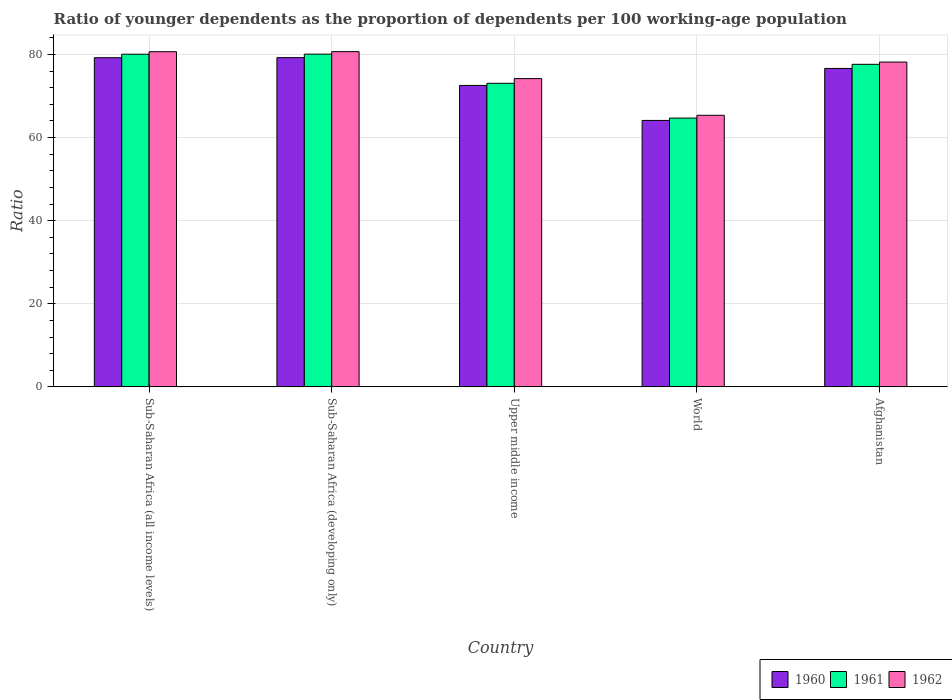How many different coloured bars are there?
Provide a succinct answer. 3. How many groups of bars are there?
Keep it short and to the point. 5. Are the number of bars on each tick of the X-axis equal?
Keep it short and to the point. Yes. How many bars are there on the 1st tick from the left?
Your answer should be compact. 3. What is the label of the 1st group of bars from the left?
Keep it short and to the point. Sub-Saharan Africa (all income levels). In how many cases, is the number of bars for a given country not equal to the number of legend labels?
Your response must be concise. 0. What is the age dependency ratio(young) in 1961 in World?
Give a very brief answer. 64.68. Across all countries, what is the maximum age dependency ratio(young) in 1962?
Ensure brevity in your answer.  80.68. Across all countries, what is the minimum age dependency ratio(young) in 1960?
Offer a very short reply. 64.12. In which country was the age dependency ratio(young) in 1960 maximum?
Your answer should be very brief. Sub-Saharan Africa (developing only). What is the total age dependency ratio(young) in 1960 in the graph?
Ensure brevity in your answer.  371.74. What is the difference between the age dependency ratio(young) in 1961 in Upper middle income and that in World?
Ensure brevity in your answer.  8.37. What is the difference between the age dependency ratio(young) in 1960 in Sub-Saharan Africa (all income levels) and the age dependency ratio(young) in 1962 in Sub-Saharan Africa (developing only)?
Ensure brevity in your answer.  -1.46. What is the average age dependency ratio(young) in 1962 per country?
Offer a very short reply. 75.81. What is the difference between the age dependency ratio(young) of/in 1961 and age dependency ratio(young) of/in 1962 in Sub-Saharan Africa (all income levels)?
Your response must be concise. -0.6. What is the ratio of the age dependency ratio(young) in 1961 in Afghanistan to that in World?
Ensure brevity in your answer.  1.2. Is the age dependency ratio(young) in 1962 in Sub-Saharan Africa (all income levels) less than that in World?
Offer a terse response. No. What is the difference between the highest and the second highest age dependency ratio(young) in 1961?
Your answer should be very brief. 0.02. What is the difference between the highest and the lowest age dependency ratio(young) in 1961?
Offer a terse response. 15.39. Is it the case that in every country, the sum of the age dependency ratio(young) in 1960 and age dependency ratio(young) in 1962 is greater than the age dependency ratio(young) in 1961?
Give a very brief answer. Yes. How many bars are there?
Provide a short and direct response. 15. How many countries are there in the graph?
Offer a terse response. 5. What is the difference between two consecutive major ticks on the Y-axis?
Provide a succinct answer. 20. Are the values on the major ticks of Y-axis written in scientific E-notation?
Make the answer very short. No. Does the graph contain any zero values?
Your answer should be compact. No. Where does the legend appear in the graph?
Ensure brevity in your answer.  Bottom right. How many legend labels are there?
Ensure brevity in your answer.  3. How are the legend labels stacked?
Offer a very short reply. Horizontal. What is the title of the graph?
Your response must be concise. Ratio of younger dependents as the proportion of dependents per 100 working-age population. Does "1992" appear as one of the legend labels in the graph?
Keep it short and to the point. No. What is the label or title of the Y-axis?
Give a very brief answer. Ratio. What is the Ratio of 1960 in Sub-Saharan Africa (all income levels)?
Your answer should be very brief. 79.21. What is the Ratio in 1961 in Sub-Saharan Africa (all income levels)?
Offer a very short reply. 80.06. What is the Ratio of 1962 in Sub-Saharan Africa (all income levels)?
Offer a terse response. 80.66. What is the Ratio of 1960 in Sub-Saharan Africa (developing only)?
Make the answer very short. 79.23. What is the Ratio of 1961 in Sub-Saharan Africa (developing only)?
Provide a succinct answer. 80.07. What is the Ratio in 1962 in Sub-Saharan Africa (developing only)?
Give a very brief answer. 80.68. What is the Ratio of 1960 in Upper middle income?
Offer a terse response. 72.54. What is the Ratio of 1961 in Upper middle income?
Your answer should be very brief. 73.05. What is the Ratio in 1962 in Upper middle income?
Keep it short and to the point. 74.18. What is the Ratio of 1960 in World?
Provide a short and direct response. 64.12. What is the Ratio of 1961 in World?
Keep it short and to the point. 64.68. What is the Ratio of 1962 in World?
Keep it short and to the point. 65.36. What is the Ratio in 1960 in Afghanistan?
Offer a terse response. 76.63. What is the Ratio in 1961 in Afghanistan?
Provide a succinct answer. 77.62. What is the Ratio in 1962 in Afghanistan?
Provide a succinct answer. 78.17. Across all countries, what is the maximum Ratio of 1960?
Provide a succinct answer. 79.23. Across all countries, what is the maximum Ratio of 1961?
Offer a very short reply. 80.07. Across all countries, what is the maximum Ratio in 1962?
Ensure brevity in your answer.  80.68. Across all countries, what is the minimum Ratio of 1960?
Ensure brevity in your answer.  64.12. Across all countries, what is the minimum Ratio in 1961?
Your answer should be compact. 64.68. Across all countries, what is the minimum Ratio of 1962?
Offer a very short reply. 65.36. What is the total Ratio in 1960 in the graph?
Give a very brief answer. 371.74. What is the total Ratio of 1961 in the graph?
Give a very brief answer. 375.49. What is the total Ratio of 1962 in the graph?
Keep it short and to the point. 379.04. What is the difference between the Ratio of 1960 in Sub-Saharan Africa (all income levels) and that in Sub-Saharan Africa (developing only)?
Give a very brief answer. -0.02. What is the difference between the Ratio in 1961 in Sub-Saharan Africa (all income levels) and that in Sub-Saharan Africa (developing only)?
Make the answer very short. -0.02. What is the difference between the Ratio in 1962 in Sub-Saharan Africa (all income levels) and that in Sub-Saharan Africa (developing only)?
Offer a terse response. -0.02. What is the difference between the Ratio of 1960 in Sub-Saharan Africa (all income levels) and that in Upper middle income?
Offer a very short reply. 6.67. What is the difference between the Ratio of 1961 in Sub-Saharan Africa (all income levels) and that in Upper middle income?
Offer a very short reply. 7. What is the difference between the Ratio in 1962 in Sub-Saharan Africa (all income levels) and that in Upper middle income?
Your answer should be compact. 6.48. What is the difference between the Ratio in 1960 in Sub-Saharan Africa (all income levels) and that in World?
Offer a very short reply. 15.09. What is the difference between the Ratio of 1961 in Sub-Saharan Africa (all income levels) and that in World?
Provide a succinct answer. 15.37. What is the difference between the Ratio of 1962 in Sub-Saharan Africa (all income levels) and that in World?
Offer a very short reply. 15.3. What is the difference between the Ratio of 1960 in Sub-Saharan Africa (all income levels) and that in Afghanistan?
Your answer should be compact. 2.58. What is the difference between the Ratio in 1961 in Sub-Saharan Africa (all income levels) and that in Afghanistan?
Provide a succinct answer. 2.43. What is the difference between the Ratio in 1962 in Sub-Saharan Africa (all income levels) and that in Afghanistan?
Provide a short and direct response. 2.49. What is the difference between the Ratio in 1960 in Sub-Saharan Africa (developing only) and that in Upper middle income?
Keep it short and to the point. 6.69. What is the difference between the Ratio of 1961 in Sub-Saharan Africa (developing only) and that in Upper middle income?
Your response must be concise. 7.02. What is the difference between the Ratio of 1962 in Sub-Saharan Africa (developing only) and that in Upper middle income?
Your answer should be very brief. 6.49. What is the difference between the Ratio of 1960 in Sub-Saharan Africa (developing only) and that in World?
Your answer should be very brief. 15.11. What is the difference between the Ratio of 1961 in Sub-Saharan Africa (developing only) and that in World?
Provide a succinct answer. 15.39. What is the difference between the Ratio in 1962 in Sub-Saharan Africa (developing only) and that in World?
Provide a short and direct response. 15.32. What is the difference between the Ratio in 1960 in Sub-Saharan Africa (developing only) and that in Afghanistan?
Your response must be concise. 2.6. What is the difference between the Ratio in 1961 in Sub-Saharan Africa (developing only) and that in Afghanistan?
Ensure brevity in your answer.  2.45. What is the difference between the Ratio of 1962 in Sub-Saharan Africa (developing only) and that in Afghanistan?
Your answer should be compact. 2.51. What is the difference between the Ratio of 1960 in Upper middle income and that in World?
Offer a very short reply. 8.42. What is the difference between the Ratio of 1961 in Upper middle income and that in World?
Provide a short and direct response. 8.37. What is the difference between the Ratio of 1962 in Upper middle income and that in World?
Your answer should be very brief. 8.82. What is the difference between the Ratio in 1960 in Upper middle income and that in Afghanistan?
Keep it short and to the point. -4.09. What is the difference between the Ratio of 1961 in Upper middle income and that in Afghanistan?
Your answer should be compact. -4.57. What is the difference between the Ratio in 1962 in Upper middle income and that in Afghanistan?
Offer a terse response. -3.98. What is the difference between the Ratio in 1960 in World and that in Afghanistan?
Your answer should be compact. -12.51. What is the difference between the Ratio in 1961 in World and that in Afghanistan?
Make the answer very short. -12.94. What is the difference between the Ratio of 1962 in World and that in Afghanistan?
Offer a terse response. -12.81. What is the difference between the Ratio in 1960 in Sub-Saharan Africa (all income levels) and the Ratio in 1961 in Sub-Saharan Africa (developing only)?
Your answer should be compact. -0.86. What is the difference between the Ratio of 1960 in Sub-Saharan Africa (all income levels) and the Ratio of 1962 in Sub-Saharan Africa (developing only)?
Provide a succinct answer. -1.46. What is the difference between the Ratio of 1961 in Sub-Saharan Africa (all income levels) and the Ratio of 1962 in Sub-Saharan Africa (developing only)?
Ensure brevity in your answer.  -0.62. What is the difference between the Ratio of 1960 in Sub-Saharan Africa (all income levels) and the Ratio of 1961 in Upper middle income?
Offer a very short reply. 6.16. What is the difference between the Ratio in 1960 in Sub-Saharan Africa (all income levels) and the Ratio in 1962 in Upper middle income?
Ensure brevity in your answer.  5.03. What is the difference between the Ratio of 1961 in Sub-Saharan Africa (all income levels) and the Ratio of 1962 in Upper middle income?
Offer a terse response. 5.87. What is the difference between the Ratio in 1960 in Sub-Saharan Africa (all income levels) and the Ratio in 1961 in World?
Your response must be concise. 14.53. What is the difference between the Ratio of 1960 in Sub-Saharan Africa (all income levels) and the Ratio of 1962 in World?
Your response must be concise. 13.86. What is the difference between the Ratio of 1961 in Sub-Saharan Africa (all income levels) and the Ratio of 1962 in World?
Provide a succinct answer. 14.7. What is the difference between the Ratio of 1960 in Sub-Saharan Africa (all income levels) and the Ratio of 1961 in Afghanistan?
Give a very brief answer. 1.59. What is the difference between the Ratio of 1960 in Sub-Saharan Africa (all income levels) and the Ratio of 1962 in Afghanistan?
Make the answer very short. 1.05. What is the difference between the Ratio of 1961 in Sub-Saharan Africa (all income levels) and the Ratio of 1962 in Afghanistan?
Give a very brief answer. 1.89. What is the difference between the Ratio of 1960 in Sub-Saharan Africa (developing only) and the Ratio of 1961 in Upper middle income?
Give a very brief answer. 6.18. What is the difference between the Ratio in 1960 in Sub-Saharan Africa (developing only) and the Ratio in 1962 in Upper middle income?
Your answer should be compact. 5.05. What is the difference between the Ratio of 1961 in Sub-Saharan Africa (developing only) and the Ratio of 1962 in Upper middle income?
Make the answer very short. 5.89. What is the difference between the Ratio of 1960 in Sub-Saharan Africa (developing only) and the Ratio of 1961 in World?
Your response must be concise. 14.55. What is the difference between the Ratio in 1960 in Sub-Saharan Africa (developing only) and the Ratio in 1962 in World?
Provide a succinct answer. 13.88. What is the difference between the Ratio in 1961 in Sub-Saharan Africa (developing only) and the Ratio in 1962 in World?
Offer a terse response. 14.72. What is the difference between the Ratio of 1960 in Sub-Saharan Africa (developing only) and the Ratio of 1961 in Afghanistan?
Your answer should be compact. 1.61. What is the difference between the Ratio in 1960 in Sub-Saharan Africa (developing only) and the Ratio in 1962 in Afghanistan?
Offer a terse response. 1.07. What is the difference between the Ratio of 1961 in Sub-Saharan Africa (developing only) and the Ratio of 1962 in Afghanistan?
Offer a terse response. 1.91. What is the difference between the Ratio of 1960 in Upper middle income and the Ratio of 1961 in World?
Offer a terse response. 7.86. What is the difference between the Ratio of 1960 in Upper middle income and the Ratio of 1962 in World?
Your answer should be very brief. 7.19. What is the difference between the Ratio of 1961 in Upper middle income and the Ratio of 1962 in World?
Give a very brief answer. 7.7. What is the difference between the Ratio in 1960 in Upper middle income and the Ratio in 1961 in Afghanistan?
Provide a succinct answer. -5.08. What is the difference between the Ratio of 1960 in Upper middle income and the Ratio of 1962 in Afghanistan?
Ensure brevity in your answer.  -5.62. What is the difference between the Ratio of 1961 in Upper middle income and the Ratio of 1962 in Afghanistan?
Ensure brevity in your answer.  -5.11. What is the difference between the Ratio of 1960 in World and the Ratio of 1961 in Afghanistan?
Your answer should be very brief. -13.5. What is the difference between the Ratio of 1960 in World and the Ratio of 1962 in Afghanistan?
Your answer should be compact. -14.04. What is the difference between the Ratio of 1961 in World and the Ratio of 1962 in Afghanistan?
Give a very brief answer. -13.48. What is the average Ratio in 1960 per country?
Provide a short and direct response. 74.35. What is the average Ratio in 1961 per country?
Make the answer very short. 75.1. What is the average Ratio of 1962 per country?
Your response must be concise. 75.81. What is the difference between the Ratio of 1960 and Ratio of 1961 in Sub-Saharan Africa (all income levels)?
Your response must be concise. -0.84. What is the difference between the Ratio of 1960 and Ratio of 1962 in Sub-Saharan Africa (all income levels)?
Provide a short and direct response. -1.44. What is the difference between the Ratio of 1961 and Ratio of 1962 in Sub-Saharan Africa (all income levels)?
Your response must be concise. -0.6. What is the difference between the Ratio in 1960 and Ratio in 1961 in Sub-Saharan Africa (developing only)?
Offer a terse response. -0.84. What is the difference between the Ratio of 1960 and Ratio of 1962 in Sub-Saharan Africa (developing only)?
Make the answer very short. -1.44. What is the difference between the Ratio of 1961 and Ratio of 1962 in Sub-Saharan Africa (developing only)?
Your response must be concise. -0.6. What is the difference between the Ratio of 1960 and Ratio of 1961 in Upper middle income?
Offer a very short reply. -0.51. What is the difference between the Ratio in 1960 and Ratio in 1962 in Upper middle income?
Provide a short and direct response. -1.64. What is the difference between the Ratio of 1961 and Ratio of 1962 in Upper middle income?
Ensure brevity in your answer.  -1.13. What is the difference between the Ratio of 1960 and Ratio of 1961 in World?
Provide a short and direct response. -0.56. What is the difference between the Ratio of 1960 and Ratio of 1962 in World?
Offer a very short reply. -1.24. What is the difference between the Ratio of 1961 and Ratio of 1962 in World?
Give a very brief answer. -0.67. What is the difference between the Ratio in 1960 and Ratio in 1961 in Afghanistan?
Ensure brevity in your answer.  -0.99. What is the difference between the Ratio in 1960 and Ratio in 1962 in Afghanistan?
Make the answer very short. -1.53. What is the difference between the Ratio of 1961 and Ratio of 1962 in Afghanistan?
Provide a short and direct response. -0.54. What is the ratio of the Ratio in 1962 in Sub-Saharan Africa (all income levels) to that in Sub-Saharan Africa (developing only)?
Keep it short and to the point. 1. What is the ratio of the Ratio of 1960 in Sub-Saharan Africa (all income levels) to that in Upper middle income?
Provide a short and direct response. 1.09. What is the ratio of the Ratio in 1961 in Sub-Saharan Africa (all income levels) to that in Upper middle income?
Ensure brevity in your answer.  1.1. What is the ratio of the Ratio of 1962 in Sub-Saharan Africa (all income levels) to that in Upper middle income?
Ensure brevity in your answer.  1.09. What is the ratio of the Ratio in 1960 in Sub-Saharan Africa (all income levels) to that in World?
Make the answer very short. 1.24. What is the ratio of the Ratio of 1961 in Sub-Saharan Africa (all income levels) to that in World?
Ensure brevity in your answer.  1.24. What is the ratio of the Ratio of 1962 in Sub-Saharan Africa (all income levels) to that in World?
Make the answer very short. 1.23. What is the ratio of the Ratio in 1960 in Sub-Saharan Africa (all income levels) to that in Afghanistan?
Offer a very short reply. 1.03. What is the ratio of the Ratio in 1961 in Sub-Saharan Africa (all income levels) to that in Afghanistan?
Your response must be concise. 1.03. What is the ratio of the Ratio in 1962 in Sub-Saharan Africa (all income levels) to that in Afghanistan?
Offer a very short reply. 1.03. What is the ratio of the Ratio of 1960 in Sub-Saharan Africa (developing only) to that in Upper middle income?
Offer a terse response. 1.09. What is the ratio of the Ratio of 1961 in Sub-Saharan Africa (developing only) to that in Upper middle income?
Offer a very short reply. 1.1. What is the ratio of the Ratio in 1962 in Sub-Saharan Africa (developing only) to that in Upper middle income?
Ensure brevity in your answer.  1.09. What is the ratio of the Ratio of 1960 in Sub-Saharan Africa (developing only) to that in World?
Offer a very short reply. 1.24. What is the ratio of the Ratio in 1961 in Sub-Saharan Africa (developing only) to that in World?
Your response must be concise. 1.24. What is the ratio of the Ratio in 1962 in Sub-Saharan Africa (developing only) to that in World?
Ensure brevity in your answer.  1.23. What is the ratio of the Ratio of 1960 in Sub-Saharan Africa (developing only) to that in Afghanistan?
Make the answer very short. 1.03. What is the ratio of the Ratio of 1961 in Sub-Saharan Africa (developing only) to that in Afghanistan?
Provide a succinct answer. 1.03. What is the ratio of the Ratio in 1962 in Sub-Saharan Africa (developing only) to that in Afghanistan?
Your answer should be very brief. 1.03. What is the ratio of the Ratio in 1960 in Upper middle income to that in World?
Provide a short and direct response. 1.13. What is the ratio of the Ratio of 1961 in Upper middle income to that in World?
Offer a very short reply. 1.13. What is the ratio of the Ratio of 1962 in Upper middle income to that in World?
Your answer should be compact. 1.14. What is the ratio of the Ratio of 1960 in Upper middle income to that in Afghanistan?
Your answer should be very brief. 0.95. What is the ratio of the Ratio in 1961 in Upper middle income to that in Afghanistan?
Give a very brief answer. 0.94. What is the ratio of the Ratio of 1962 in Upper middle income to that in Afghanistan?
Give a very brief answer. 0.95. What is the ratio of the Ratio in 1960 in World to that in Afghanistan?
Your answer should be very brief. 0.84. What is the ratio of the Ratio in 1962 in World to that in Afghanistan?
Provide a succinct answer. 0.84. What is the difference between the highest and the second highest Ratio in 1960?
Your answer should be compact. 0.02. What is the difference between the highest and the second highest Ratio in 1961?
Provide a short and direct response. 0.02. What is the difference between the highest and the second highest Ratio of 1962?
Offer a terse response. 0.02. What is the difference between the highest and the lowest Ratio in 1960?
Your answer should be compact. 15.11. What is the difference between the highest and the lowest Ratio of 1961?
Keep it short and to the point. 15.39. What is the difference between the highest and the lowest Ratio of 1962?
Give a very brief answer. 15.32. 